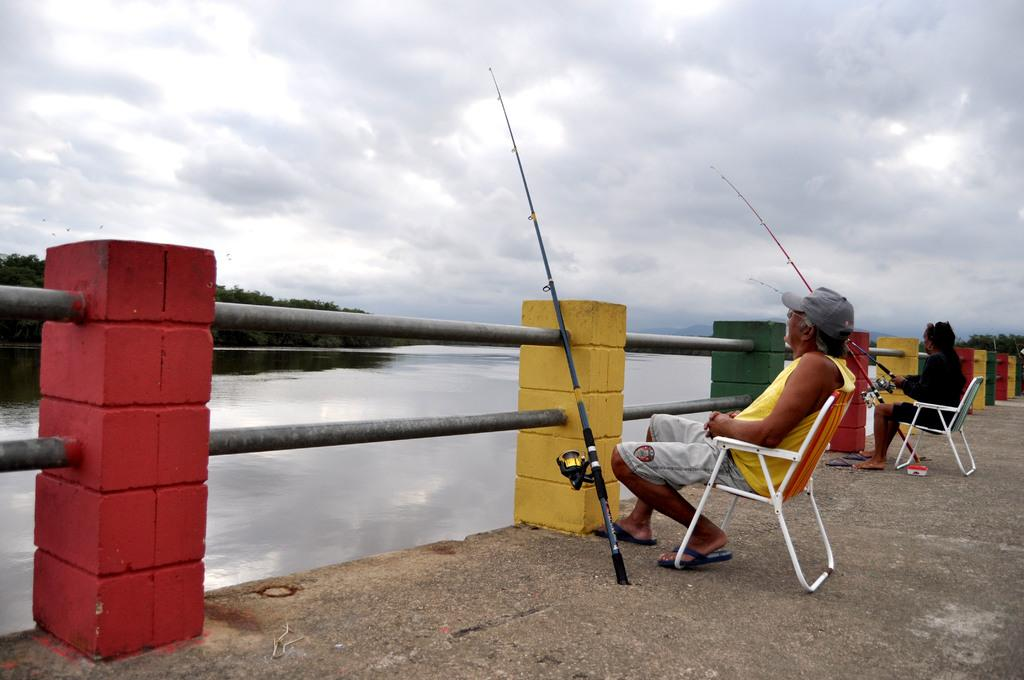How many people are in the foreground of the image? There are two men in the foreground of the image. What are the men doing in the image? The men are sitting on chairs and fishing. What objects are near the railing in the image? Fishing rods are near the railing in the image. What can be seen in the background of the image? There is water, trees, and the sky visible in the background of the image. What type of hat is the beast wearing in the image? There is no beast present in the image, and therefore no hat can be observed. 